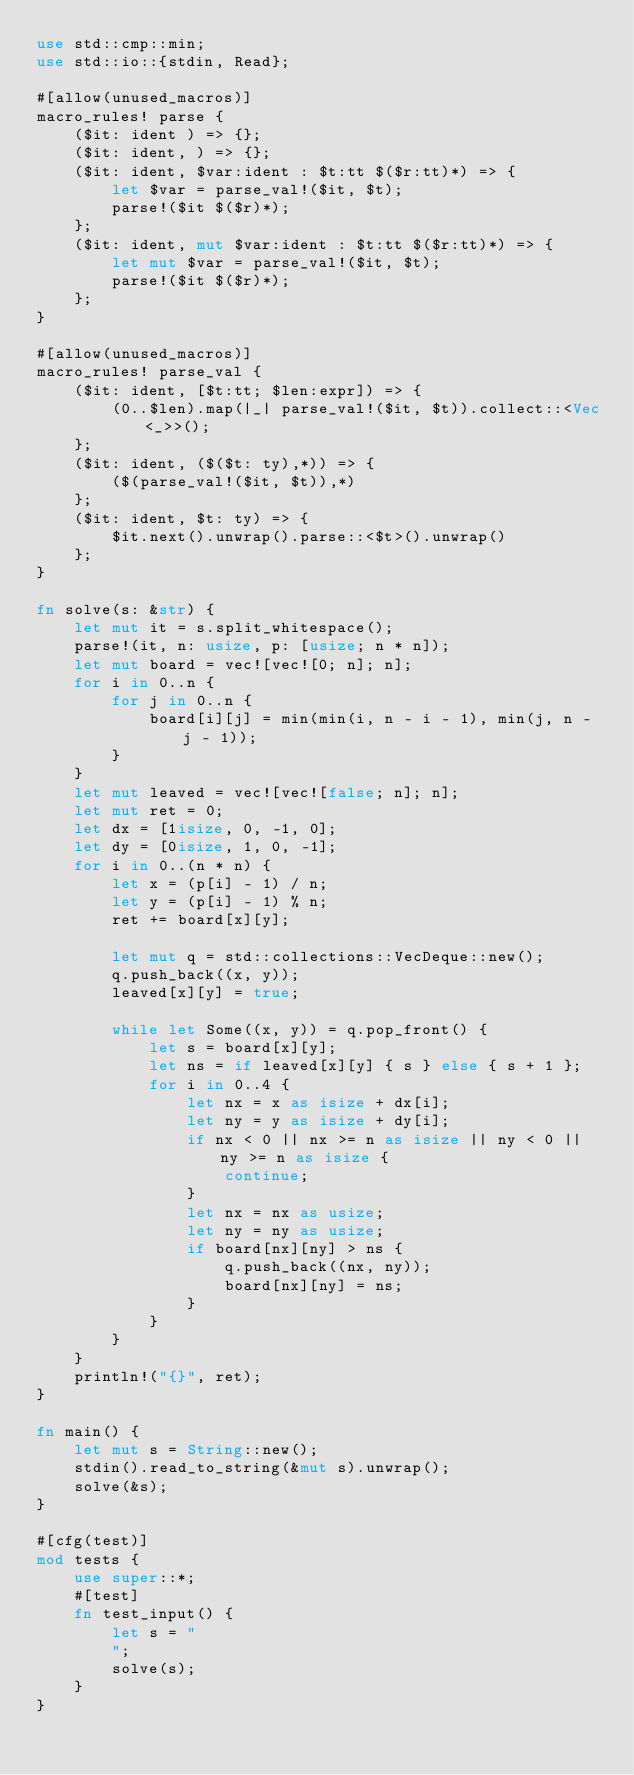Convert code to text. <code><loc_0><loc_0><loc_500><loc_500><_Rust_>use std::cmp::min;
use std::io::{stdin, Read};

#[allow(unused_macros)]
macro_rules! parse {
    ($it: ident ) => {};
    ($it: ident, ) => {};
    ($it: ident, $var:ident : $t:tt $($r:tt)*) => {
        let $var = parse_val!($it, $t);
        parse!($it $($r)*);
    };
    ($it: ident, mut $var:ident : $t:tt $($r:tt)*) => {
        let mut $var = parse_val!($it, $t);
        parse!($it $($r)*);
    };
}

#[allow(unused_macros)]
macro_rules! parse_val {
    ($it: ident, [$t:tt; $len:expr]) => {
        (0..$len).map(|_| parse_val!($it, $t)).collect::<Vec<_>>();
    };
    ($it: ident, ($($t: ty),*)) => {
        ($(parse_val!($it, $t)),*)
    };
    ($it: ident, $t: ty) => {
        $it.next().unwrap().parse::<$t>().unwrap()
    };
}

fn solve(s: &str) {
    let mut it = s.split_whitespace();
    parse!(it, n: usize, p: [usize; n * n]);
    let mut board = vec![vec![0; n]; n];
    for i in 0..n {
        for j in 0..n {
            board[i][j] = min(min(i, n - i - 1), min(j, n - j - 1));
        }
    }
    let mut leaved = vec![vec![false; n]; n];
    let mut ret = 0;
    let dx = [1isize, 0, -1, 0];
    let dy = [0isize, 1, 0, -1];
    for i in 0..(n * n) {
        let x = (p[i] - 1) / n;
        let y = (p[i] - 1) % n;
        ret += board[x][y];

        let mut q = std::collections::VecDeque::new();
        q.push_back((x, y));
        leaved[x][y] = true;

        while let Some((x, y)) = q.pop_front() {
            let s = board[x][y];
            let ns = if leaved[x][y] { s } else { s + 1 };
            for i in 0..4 {
                let nx = x as isize + dx[i];
                let ny = y as isize + dy[i];
                if nx < 0 || nx >= n as isize || ny < 0 || ny >= n as isize {
                    continue;
                }
                let nx = nx as usize;
                let ny = ny as usize;
                if board[nx][ny] > ns {
                    q.push_back((nx, ny));
                    board[nx][ny] = ns;
                }
            }
        }
    }
    println!("{}", ret);
}

fn main() {
    let mut s = String::new();
    stdin().read_to_string(&mut s).unwrap();
    solve(&s);
}

#[cfg(test)]
mod tests {
    use super::*;
    #[test]
    fn test_input() {
        let s = "
        ";
        solve(s);
    }
}
</code> 